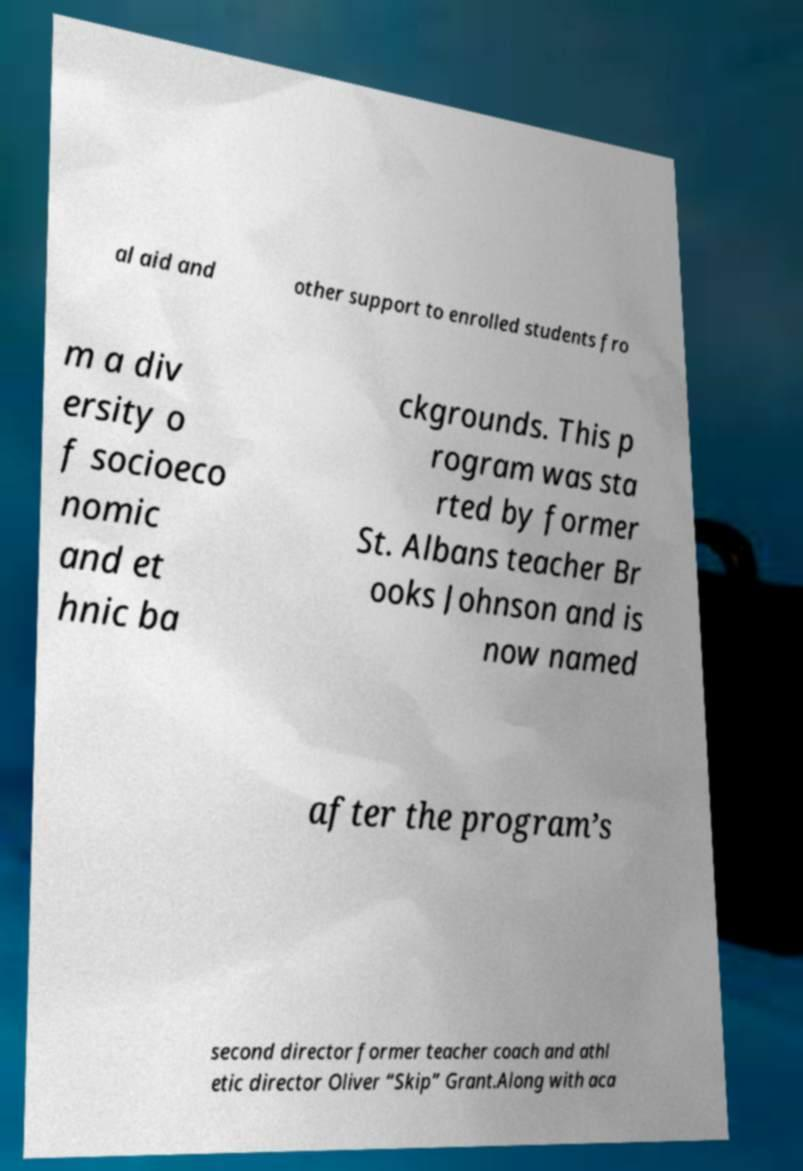Can you accurately transcribe the text from the provided image for me? al aid and other support to enrolled students fro m a div ersity o f socioeco nomic and et hnic ba ckgrounds. This p rogram was sta rted by former St. Albans teacher Br ooks Johnson and is now named after the program’s second director former teacher coach and athl etic director Oliver “Skip” Grant.Along with aca 